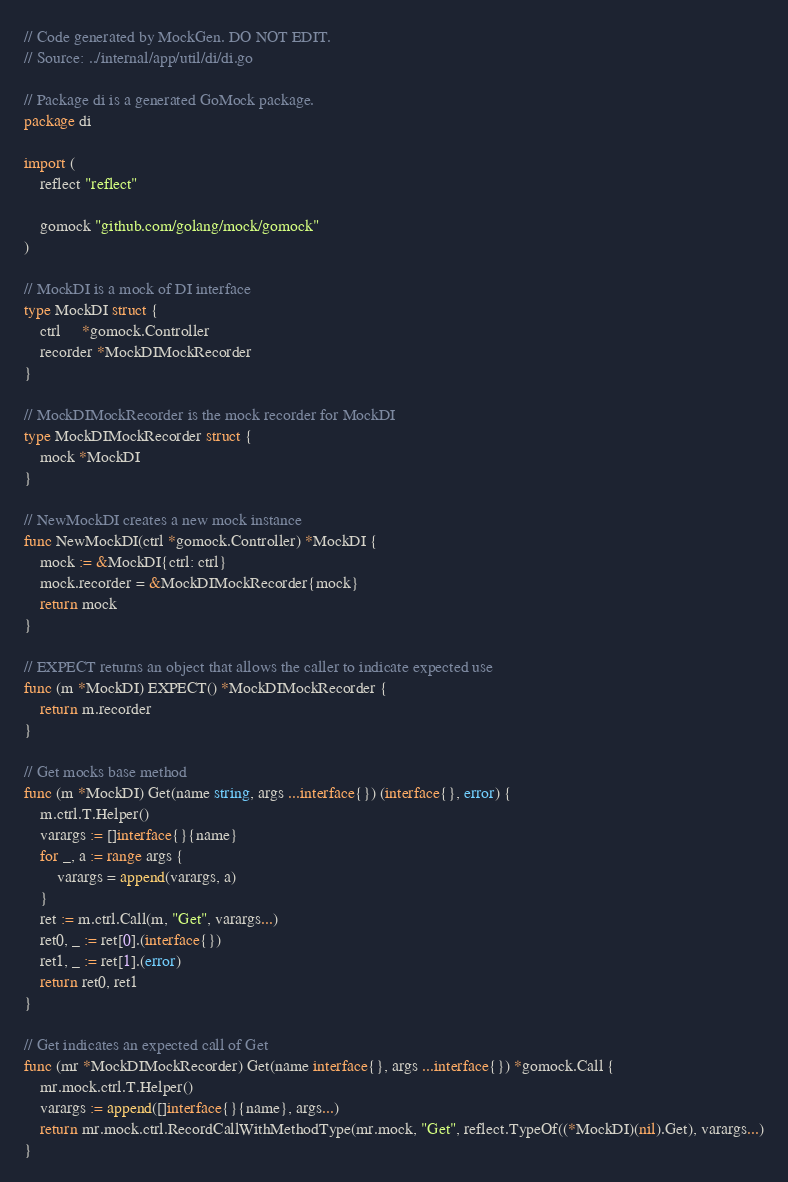<code> <loc_0><loc_0><loc_500><loc_500><_Go_>// Code generated by MockGen. DO NOT EDIT.
// Source: ../internal/app/util/di/di.go

// Package di is a generated GoMock package.
package di

import (
	reflect "reflect"

	gomock "github.com/golang/mock/gomock"
)

// MockDI is a mock of DI interface
type MockDI struct {
	ctrl     *gomock.Controller
	recorder *MockDIMockRecorder
}

// MockDIMockRecorder is the mock recorder for MockDI
type MockDIMockRecorder struct {
	mock *MockDI
}

// NewMockDI creates a new mock instance
func NewMockDI(ctrl *gomock.Controller) *MockDI {
	mock := &MockDI{ctrl: ctrl}
	mock.recorder = &MockDIMockRecorder{mock}
	return mock
}

// EXPECT returns an object that allows the caller to indicate expected use
func (m *MockDI) EXPECT() *MockDIMockRecorder {
	return m.recorder
}

// Get mocks base method
func (m *MockDI) Get(name string, args ...interface{}) (interface{}, error) {
	m.ctrl.T.Helper()
	varargs := []interface{}{name}
	for _, a := range args {
		varargs = append(varargs, a)
	}
	ret := m.ctrl.Call(m, "Get", varargs...)
	ret0, _ := ret[0].(interface{})
	ret1, _ := ret[1].(error)
	return ret0, ret1
}

// Get indicates an expected call of Get
func (mr *MockDIMockRecorder) Get(name interface{}, args ...interface{}) *gomock.Call {
	mr.mock.ctrl.T.Helper()
	varargs := append([]interface{}{name}, args...)
	return mr.mock.ctrl.RecordCallWithMethodType(mr.mock, "Get", reflect.TypeOf((*MockDI)(nil).Get), varargs...)
}
</code> 